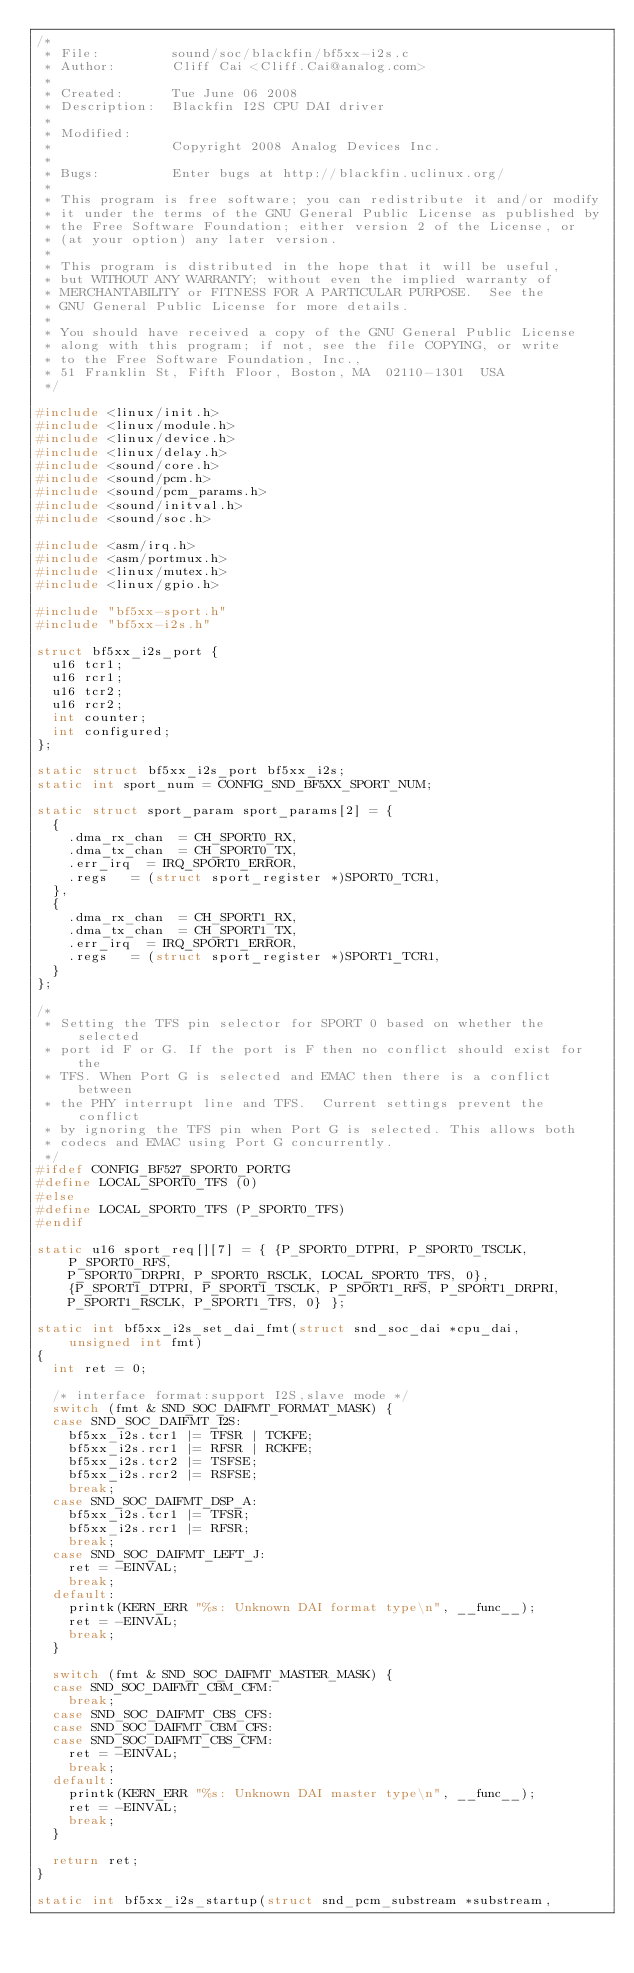<code> <loc_0><loc_0><loc_500><loc_500><_C_>/*
 * File:         sound/soc/blackfin/bf5xx-i2s.c
 * Author:       Cliff Cai <Cliff.Cai@analog.com>
 *
 * Created:      Tue June 06 2008
 * Description:  Blackfin I2S CPU DAI driver
 *
 * Modified:
 *               Copyright 2008 Analog Devices Inc.
 *
 * Bugs:         Enter bugs at http://blackfin.uclinux.org/
 *
 * This program is free software; you can redistribute it and/or modify
 * it under the terms of the GNU General Public License as published by
 * the Free Software Foundation; either version 2 of the License, or
 * (at your option) any later version.
 *
 * This program is distributed in the hope that it will be useful,
 * but WITHOUT ANY WARRANTY; without even the implied warranty of
 * MERCHANTABILITY or FITNESS FOR A PARTICULAR PURPOSE.  See the
 * GNU General Public License for more details.
 *
 * You should have received a copy of the GNU General Public License
 * along with this program; if not, see the file COPYING, or write
 * to the Free Software Foundation, Inc.,
 * 51 Franklin St, Fifth Floor, Boston, MA  02110-1301  USA
 */

#include <linux/init.h>
#include <linux/module.h>
#include <linux/device.h>
#include <linux/delay.h>
#include <sound/core.h>
#include <sound/pcm.h>
#include <sound/pcm_params.h>
#include <sound/initval.h>
#include <sound/soc.h>

#include <asm/irq.h>
#include <asm/portmux.h>
#include <linux/mutex.h>
#include <linux/gpio.h>

#include "bf5xx-sport.h"
#include "bf5xx-i2s.h"

struct bf5xx_i2s_port {
	u16 tcr1;
	u16 rcr1;
	u16 tcr2;
	u16 rcr2;
	int counter;
	int configured;
};

static struct bf5xx_i2s_port bf5xx_i2s;
static int sport_num = CONFIG_SND_BF5XX_SPORT_NUM;

static struct sport_param sport_params[2] = {
	{
		.dma_rx_chan	= CH_SPORT0_RX,
		.dma_tx_chan	= CH_SPORT0_TX,
		.err_irq	= IRQ_SPORT0_ERROR,
		.regs		= (struct sport_register *)SPORT0_TCR1,
	},
	{
		.dma_rx_chan	= CH_SPORT1_RX,
		.dma_tx_chan	= CH_SPORT1_TX,
		.err_irq	= IRQ_SPORT1_ERROR,
		.regs		= (struct sport_register *)SPORT1_TCR1,
	}
};

/*
 * Setting the TFS pin selector for SPORT 0 based on whether the selected
 * port id F or G. If the port is F then no conflict should exist for the
 * TFS. When Port G is selected and EMAC then there is a conflict between
 * the PHY interrupt line and TFS.  Current settings prevent the conflict
 * by ignoring the TFS pin when Port G is selected. This allows both
 * codecs and EMAC using Port G concurrently.
 */
#ifdef CONFIG_BF527_SPORT0_PORTG
#define LOCAL_SPORT0_TFS (0)
#else
#define LOCAL_SPORT0_TFS (P_SPORT0_TFS)
#endif

static u16 sport_req[][7] = { {P_SPORT0_DTPRI, P_SPORT0_TSCLK, P_SPORT0_RFS,
		P_SPORT0_DRPRI, P_SPORT0_RSCLK, LOCAL_SPORT0_TFS, 0},
		{P_SPORT1_DTPRI, P_SPORT1_TSCLK, P_SPORT1_RFS, P_SPORT1_DRPRI,
		P_SPORT1_RSCLK, P_SPORT1_TFS, 0} };

static int bf5xx_i2s_set_dai_fmt(struct snd_soc_dai *cpu_dai,
		unsigned int fmt)
{
	int ret = 0;

	/* interface format:support I2S,slave mode */
	switch (fmt & SND_SOC_DAIFMT_FORMAT_MASK) {
	case SND_SOC_DAIFMT_I2S:
		bf5xx_i2s.tcr1 |= TFSR | TCKFE;
		bf5xx_i2s.rcr1 |= RFSR | RCKFE;
		bf5xx_i2s.tcr2 |= TSFSE;
		bf5xx_i2s.rcr2 |= RSFSE;
		break;
	case SND_SOC_DAIFMT_DSP_A:
		bf5xx_i2s.tcr1 |= TFSR;
		bf5xx_i2s.rcr1 |= RFSR;
		break;
	case SND_SOC_DAIFMT_LEFT_J:
		ret = -EINVAL;
		break;
	default:
		printk(KERN_ERR "%s: Unknown DAI format type\n", __func__);
		ret = -EINVAL;
		break;
	}

	switch (fmt & SND_SOC_DAIFMT_MASTER_MASK) {
	case SND_SOC_DAIFMT_CBM_CFM:
		break;
	case SND_SOC_DAIFMT_CBS_CFS:
	case SND_SOC_DAIFMT_CBM_CFS:
	case SND_SOC_DAIFMT_CBS_CFM:
		ret = -EINVAL;
		break;
	default:
		printk(KERN_ERR "%s: Unknown DAI master type\n", __func__);
		ret = -EINVAL;
		break;
	}

	return ret;
}

static int bf5xx_i2s_startup(struct snd_pcm_substream *substream,</code> 